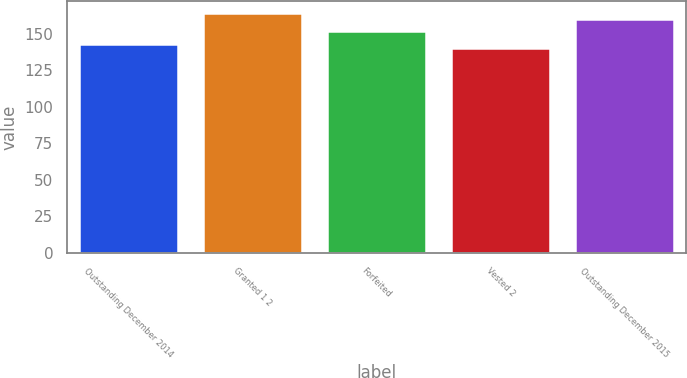<chart> <loc_0><loc_0><loc_500><loc_500><bar_chart><fcel>Outstanding December 2014<fcel>Granted 1 2<fcel>Forfeited<fcel>Vested 2<fcel>Outstanding December 2015<nl><fcel>143.07<fcel>164.23<fcel>152.06<fcel>140.29<fcel>159.82<nl></chart> 